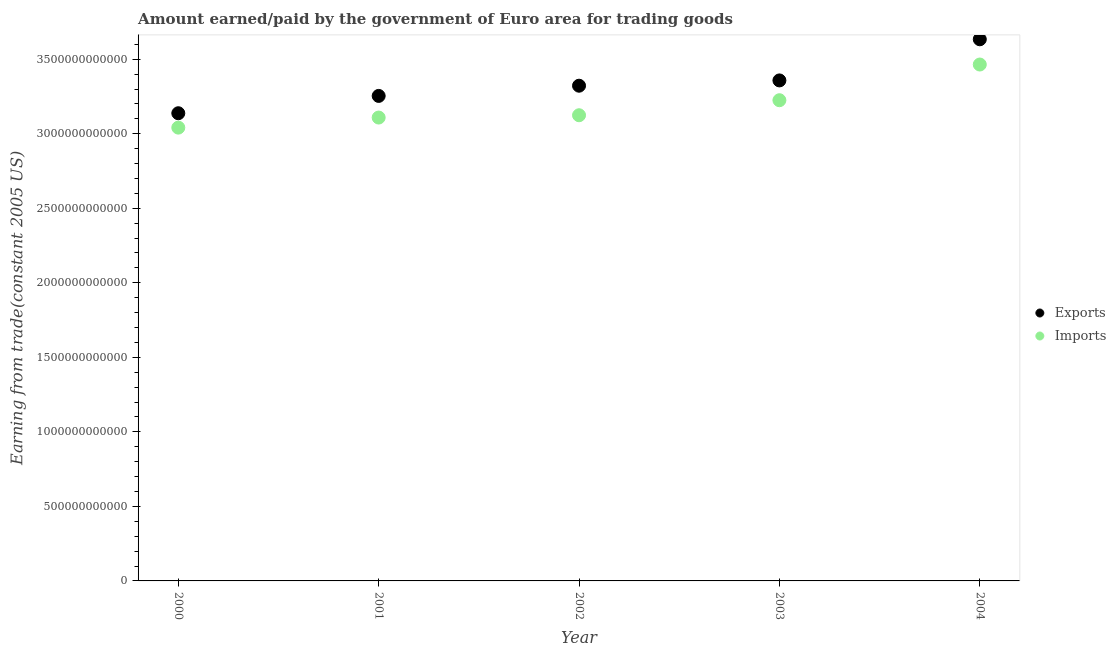How many different coloured dotlines are there?
Provide a succinct answer. 2. What is the amount earned from exports in 2000?
Give a very brief answer. 3.14e+12. Across all years, what is the maximum amount paid for imports?
Your response must be concise. 3.46e+12. Across all years, what is the minimum amount earned from exports?
Your answer should be compact. 3.14e+12. In which year was the amount earned from exports maximum?
Offer a terse response. 2004. What is the total amount earned from exports in the graph?
Offer a terse response. 1.67e+13. What is the difference between the amount paid for imports in 2000 and that in 2003?
Provide a succinct answer. -1.84e+11. What is the difference between the amount earned from exports in 2003 and the amount paid for imports in 2000?
Provide a short and direct response. 3.17e+11. What is the average amount earned from exports per year?
Make the answer very short. 3.34e+12. In the year 2004, what is the difference between the amount earned from exports and amount paid for imports?
Your response must be concise. 1.69e+11. In how many years, is the amount earned from exports greater than 2500000000000 US$?
Keep it short and to the point. 5. What is the ratio of the amount earned from exports in 2001 to that in 2003?
Your answer should be compact. 0.97. Is the difference between the amount paid for imports in 2000 and 2001 greater than the difference between the amount earned from exports in 2000 and 2001?
Ensure brevity in your answer.  Yes. What is the difference between the highest and the second highest amount earned from exports?
Provide a short and direct response. 2.76e+11. What is the difference between the highest and the lowest amount paid for imports?
Make the answer very short. 4.23e+11. In how many years, is the amount paid for imports greater than the average amount paid for imports taken over all years?
Your response must be concise. 2. Does the amount earned from exports monotonically increase over the years?
Ensure brevity in your answer.  Yes. Is the amount paid for imports strictly greater than the amount earned from exports over the years?
Your response must be concise. No. Is the amount paid for imports strictly less than the amount earned from exports over the years?
Provide a short and direct response. Yes. How many years are there in the graph?
Give a very brief answer. 5. What is the difference between two consecutive major ticks on the Y-axis?
Your response must be concise. 5.00e+11. Does the graph contain any zero values?
Your answer should be very brief. No. Does the graph contain grids?
Your answer should be very brief. No. Where does the legend appear in the graph?
Make the answer very short. Center right. How are the legend labels stacked?
Offer a terse response. Vertical. What is the title of the graph?
Keep it short and to the point. Amount earned/paid by the government of Euro area for trading goods. Does "Investment in Telecom" appear as one of the legend labels in the graph?
Keep it short and to the point. No. What is the label or title of the X-axis?
Ensure brevity in your answer.  Year. What is the label or title of the Y-axis?
Provide a short and direct response. Earning from trade(constant 2005 US). What is the Earning from trade(constant 2005 US) in Exports in 2000?
Give a very brief answer. 3.14e+12. What is the Earning from trade(constant 2005 US) of Imports in 2000?
Provide a short and direct response. 3.04e+12. What is the Earning from trade(constant 2005 US) of Exports in 2001?
Give a very brief answer. 3.25e+12. What is the Earning from trade(constant 2005 US) in Imports in 2001?
Give a very brief answer. 3.11e+12. What is the Earning from trade(constant 2005 US) of Exports in 2002?
Provide a short and direct response. 3.32e+12. What is the Earning from trade(constant 2005 US) of Imports in 2002?
Keep it short and to the point. 3.12e+12. What is the Earning from trade(constant 2005 US) in Exports in 2003?
Offer a terse response. 3.36e+12. What is the Earning from trade(constant 2005 US) of Imports in 2003?
Your response must be concise. 3.22e+12. What is the Earning from trade(constant 2005 US) of Exports in 2004?
Give a very brief answer. 3.63e+12. What is the Earning from trade(constant 2005 US) in Imports in 2004?
Provide a short and direct response. 3.46e+12. Across all years, what is the maximum Earning from trade(constant 2005 US) of Exports?
Offer a very short reply. 3.63e+12. Across all years, what is the maximum Earning from trade(constant 2005 US) in Imports?
Your response must be concise. 3.46e+12. Across all years, what is the minimum Earning from trade(constant 2005 US) in Exports?
Your response must be concise. 3.14e+12. Across all years, what is the minimum Earning from trade(constant 2005 US) of Imports?
Provide a short and direct response. 3.04e+12. What is the total Earning from trade(constant 2005 US) of Exports in the graph?
Provide a succinct answer. 1.67e+13. What is the total Earning from trade(constant 2005 US) of Imports in the graph?
Offer a very short reply. 1.60e+13. What is the difference between the Earning from trade(constant 2005 US) in Exports in 2000 and that in 2001?
Keep it short and to the point. -1.16e+11. What is the difference between the Earning from trade(constant 2005 US) in Imports in 2000 and that in 2001?
Provide a short and direct response. -6.76e+1. What is the difference between the Earning from trade(constant 2005 US) of Exports in 2000 and that in 2002?
Your answer should be very brief. -1.85e+11. What is the difference between the Earning from trade(constant 2005 US) of Imports in 2000 and that in 2002?
Provide a succinct answer. -8.30e+1. What is the difference between the Earning from trade(constant 2005 US) of Exports in 2000 and that in 2003?
Offer a terse response. -2.20e+11. What is the difference between the Earning from trade(constant 2005 US) in Imports in 2000 and that in 2003?
Your answer should be compact. -1.84e+11. What is the difference between the Earning from trade(constant 2005 US) in Exports in 2000 and that in 2004?
Offer a very short reply. -4.96e+11. What is the difference between the Earning from trade(constant 2005 US) in Imports in 2000 and that in 2004?
Keep it short and to the point. -4.23e+11. What is the difference between the Earning from trade(constant 2005 US) in Exports in 2001 and that in 2002?
Ensure brevity in your answer.  -6.85e+1. What is the difference between the Earning from trade(constant 2005 US) in Imports in 2001 and that in 2002?
Your response must be concise. -1.54e+1. What is the difference between the Earning from trade(constant 2005 US) of Exports in 2001 and that in 2003?
Provide a short and direct response. -1.04e+11. What is the difference between the Earning from trade(constant 2005 US) of Imports in 2001 and that in 2003?
Offer a terse response. -1.16e+11. What is the difference between the Earning from trade(constant 2005 US) of Exports in 2001 and that in 2004?
Offer a terse response. -3.80e+11. What is the difference between the Earning from trade(constant 2005 US) in Imports in 2001 and that in 2004?
Keep it short and to the point. -3.56e+11. What is the difference between the Earning from trade(constant 2005 US) of Exports in 2002 and that in 2003?
Provide a short and direct response. -3.55e+1. What is the difference between the Earning from trade(constant 2005 US) of Imports in 2002 and that in 2003?
Provide a short and direct response. -1.01e+11. What is the difference between the Earning from trade(constant 2005 US) of Exports in 2002 and that in 2004?
Make the answer very short. -3.11e+11. What is the difference between the Earning from trade(constant 2005 US) in Imports in 2002 and that in 2004?
Offer a terse response. -3.40e+11. What is the difference between the Earning from trade(constant 2005 US) of Exports in 2003 and that in 2004?
Keep it short and to the point. -2.76e+11. What is the difference between the Earning from trade(constant 2005 US) of Imports in 2003 and that in 2004?
Give a very brief answer. -2.39e+11. What is the difference between the Earning from trade(constant 2005 US) in Exports in 2000 and the Earning from trade(constant 2005 US) in Imports in 2001?
Provide a short and direct response. 2.89e+1. What is the difference between the Earning from trade(constant 2005 US) of Exports in 2000 and the Earning from trade(constant 2005 US) of Imports in 2002?
Your answer should be very brief. 1.35e+1. What is the difference between the Earning from trade(constant 2005 US) in Exports in 2000 and the Earning from trade(constant 2005 US) in Imports in 2003?
Offer a terse response. -8.73e+1. What is the difference between the Earning from trade(constant 2005 US) in Exports in 2000 and the Earning from trade(constant 2005 US) in Imports in 2004?
Your answer should be compact. -3.27e+11. What is the difference between the Earning from trade(constant 2005 US) in Exports in 2001 and the Earning from trade(constant 2005 US) in Imports in 2002?
Keep it short and to the point. 1.30e+11. What is the difference between the Earning from trade(constant 2005 US) in Exports in 2001 and the Earning from trade(constant 2005 US) in Imports in 2003?
Offer a terse response. 2.89e+1. What is the difference between the Earning from trade(constant 2005 US) in Exports in 2001 and the Earning from trade(constant 2005 US) in Imports in 2004?
Ensure brevity in your answer.  -2.11e+11. What is the difference between the Earning from trade(constant 2005 US) in Exports in 2002 and the Earning from trade(constant 2005 US) in Imports in 2003?
Make the answer very short. 9.74e+1. What is the difference between the Earning from trade(constant 2005 US) in Exports in 2002 and the Earning from trade(constant 2005 US) in Imports in 2004?
Offer a terse response. -1.42e+11. What is the difference between the Earning from trade(constant 2005 US) in Exports in 2003 and the Earning from trade(constant 2005 US) in Imports in 2004?
Your answer should be compact. -1.07e+11. What is the average Earning from trade(constant 2005 US) in Exports per year?
Provide a short and direct response. 3.34e+12. What is the average Earning from trade(constant 2005 US) in Imports per year?
Keep it short and to the point. 3.19e+12. In the year 2000, what is the difference between the Earning from trade(constant 2005 US) in Exports and Earning from trade(constant 2005 US) in Imports?
Give a very brief answer. 9.65e+1. In the year 2001, what is the difference between the Earning from trade(constant 2005 US) of Exports and Earning from trade(constant 2005 US) of Imports?
Provide a short and direct response. 1.45e+11. In the year 2002, what is the difference between the Earning from trade(constant 2005 US) of Exports and Earning from trade(constant 2005 US) of Imports?
Provide a short and direct response. 1.98e+11. In the year 2003, what is the difference between the Earning from trade(constant 2005 US) in Exports and Earning from trade(constant 2005 US) in Imports?
Provide a succinct answer. 1.33e+11. In the year 2004, what is the difference between the Earning from trade(constant 2005 US) in Exports and Earning from trade(constant 2005 US) in Imports?
Your answer should be compact. 1.69e+11. What is the ratio of the Earning from trade(constant 2005 US) of Exports in 2000 to that in 2001?
Your answer should be compact. 0.96. What is the ratio of the Earning from trade(constant 2005 US) of Imports in 2000 to that in 2001?
Your response must be concise. 0.98. What is the ratio of the Earning from trade(constant 2005 US) of Imports in 2000 to that in 2002?
Provide a succinct answer. 0.97. What is the ratio of the Earning from trade(constant 2005 US) in Exports in 2000 to that in 2003?
Offer a very short reply. 0.93. What is the ratio of the Earning from trade(constant 2005 US) in Imports in 2000 to that in 2003?
Make the answer very short. 0.94. What is the ratio of the Earning from trade(constant 2005 US) in Exports in 2000 to that in 2004?
Give a very brief answer. 0.86. What is the ratio of the Earning from trade(constant 2005 US) of Imports in 2000 to that in 2004?
Offer a terse response. 0.88. What is the ratio of the Earning from trade(constant 2005 US) in Exports in 2001 to that in 2002?
Provide a short and direct response. 0.98. What is the ratio of the Earning from trade(constant 2005 US) of Exports in 2001 to that in 2003?
Provide a short and direct response. 0.97. What is the ratio of the Earning from trade(constant 2005 US) in Imports in 2001 to that in 2003?
Your answer should be very brief. 0.96. What is the ratio of the Earning from trade(constant 2005 US) of Exports in 2001 to that in 2004?
Your answer should be compact. 0.9. What is the ratio of the Earning from trade(constant 2005 US) in Imports in 2001 to that in 2004?
Give a very brief answer. 0.9. What is the ratio of the Earning from trade(constant 2005 US) of Exports in 2002 to that in 2003?
Your answer should be compact. 0.99. What is the ratio of the Earning from trade(constant 2005 US) of Imports in 2002 to that in 2003?
Your answer should be very brief. 0.97. What is the ratio of the Earning from trade(constant 2005 US) of Exports in 2002 to that in 2004?
Your response must be concise. 0.91. What is the ratio of the Earning from trade(constant 2005 US) of Imports in 2002 to that in 2004?
Your response must be concise. 0.9. What is the ratio of the Earning from trade(constant 2005 US) of Exports in 2003 to that in 2004?
Make the answer very short. 0.92. What is the ratio of the Earning from trade(constant 2005 US) of Imports in 2003 to that in 2004?
Keep it short and to the point. 0.93. What is the difference between the highest and the second highest Earning from trade(constant 2005 US) in Exports?
Offer a very short reply. 2.76e+11. What is the difference between the highest and the second highest Earning from trade(constant 2005 US) of Imports?
Offer a terse response. 2.39e+11. What is the difference between the highest and the lowest Earning from trade(constant 2005 US) in Exports?
Keep it short and to the point. 4.96e+11. What is the difference between the highest and the lowest Earning from trade(constant 2005 US) in Imports?
Your answer should be very brief. 4.23e+11. 